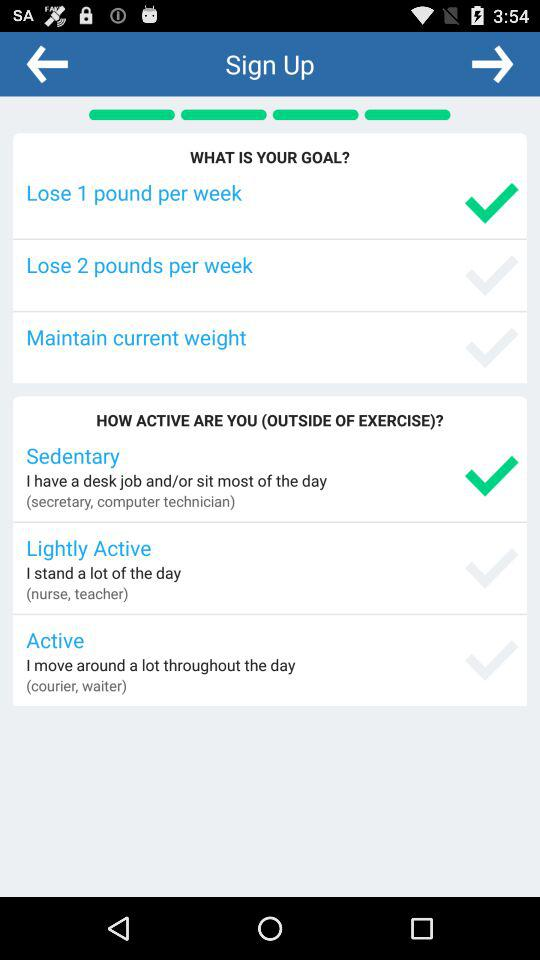How many weight loss goals are there?
Answer the question using a single word or phrase. 3 